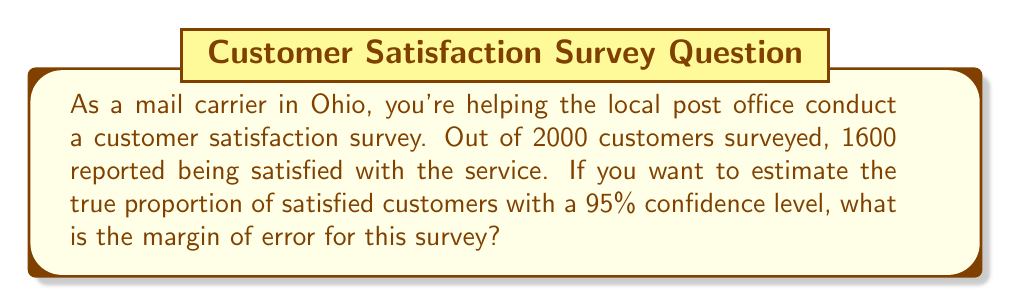Solve this math problem. Let's approach this step-by-step:

1) First, we need to identify the components of the margin of error formula:

   $\text{Margin of Error} = z^* \sqrt{\frac{p(1-p)}{n}}$

   Where:
   $z^*$ is the critical value for the desired confidence level
   $p$ is the sample proportion
   $n$ is the sample size

2) For a 95% confidence level, $z^* = 1.96$

3) Calculate the sample proportion $p$:
   $p = \frac{1600}{2000} = 0.8$

4) We know $n = 2000$

5) Now, let's plug these values into the formula:

   $\text{Margin of Error} = 1.96 \sqrt{\frac{0.8(1-0.8)}{2000}}$

6) Simplify:
   $= 1.96 \sqrt{\frac{0.8(0.2)}{2000}}$
   $= 1.96 \sqrt{\frac{0.16}{2000}}$
   $= 1.96 \sqrt{0.00008}$
   $= 1.96 (0.00894)$
   $= 0.017524$

7) Round to three decimal places:
   $= 0.018$ or $1.8\%$

Therefore, the margin of error is approximately 0.018 or 1.8%.
Answer: 0.018 or 1.8% 